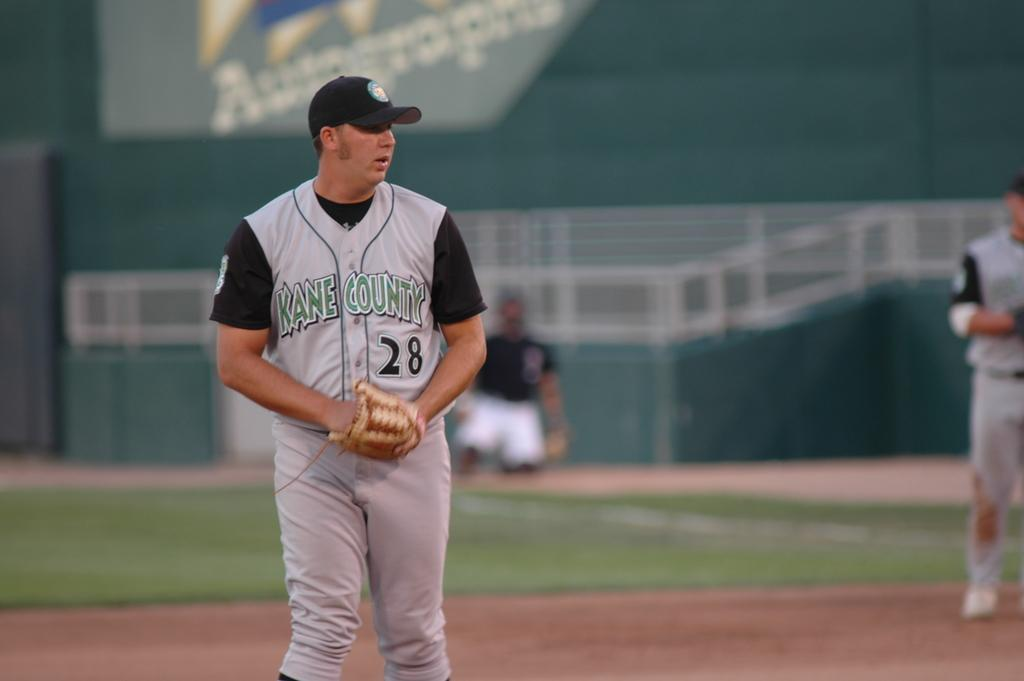<image>
Describe the image concisely. a baseball player in a 28 jersey that says Kane County 